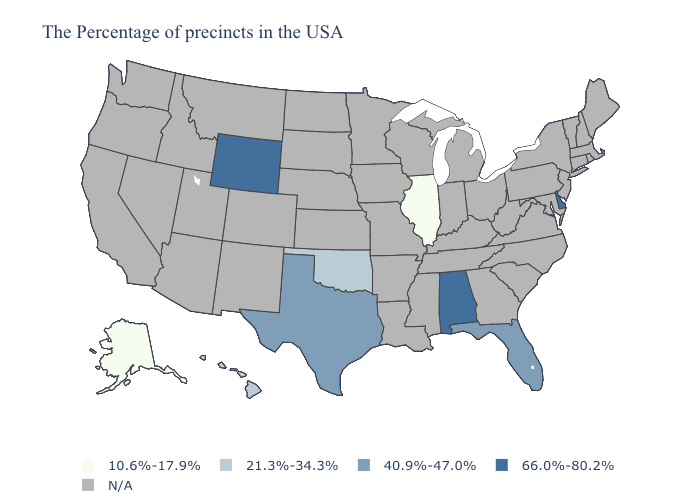What is the value of Kansas?
Give a very brief answer. N/A. Name the states that have a value in the range 10.6%-17.9%?
Be succinct. Illinois, Alaska. Name the states that have a value in the range N/A?
Short answer required. Maine, Massachusetts, Rhode Island, New Hampshire, Vermont, Connecticut, New York, New Jersey, Maryland, Pennsylvania, Virginia, North Carolina, South Carolina, West Virginia, Ohio, Georgia, Michigan, Kentucky, Indiana, Tennessee, Wisconsin, Mississippi, Louisiana, Missouri, Arkansas, Minnesota, Iowa, Kansas, Nebraska, South Dakota, North Dakota, Colorado, New Mexico, Utah, Montana, Arizona, Idaho, Nevada, California, Washington, Oregon. Does Oklahoma have the highest value in the South?
Answer briefly. No. Which states hav the highest value in the South?
Keep it brief. Delaware, Alabama. Name the states that have a value in the range 66.0%-80.2%?
Concise answer only. Delaware, Alabama, Wyoming. Is the legend a continuous bar?
Be succinct. No. What is the value of California?
Concise answer only. N/A. Is the legend a continuous bar?
Write a very short answer. No. Name the states that have a value in the range N/A?
Answer briefly. Maine, Massachusetts, Rhode Island, New Hampshire, Vermont, Connecticut, New York, New Jersey, Maryland, Pennsylvania, Virginia, North Carolina, South Carolina, West Virginia, Ohio, Georgia, Michigan, Kentucky, Indiana, Tennessee, Wisconsin, Mississippi, Louisiana, Missouri, Arkansas, Minnesota, Iowa, Kansas, Nebraska, South Dakota, North Dakota, Colorado, New Mexico, Utah, Montana, Arizona, Idaho, Nevada, California, Washington, Oregon. Is the legend a continuous bar?
Give a very brief answer. No. What is the value of Virginia?
Keep it brief. N/A. Which states hav the highest value in the West?
Give a very brief answer. Wyoming. 